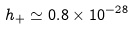<formula> <loc_0><loc_0><loc_500><loc_500>h _ { + } \simeq 0 . 8 \times 1 0 ^ { - 2 8 }</formula> 